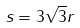Convert formula to latex. <formula><loc_0><loc_0><loc_500><loc_500>s = 3 \sqrt { 3 } r</formula> 